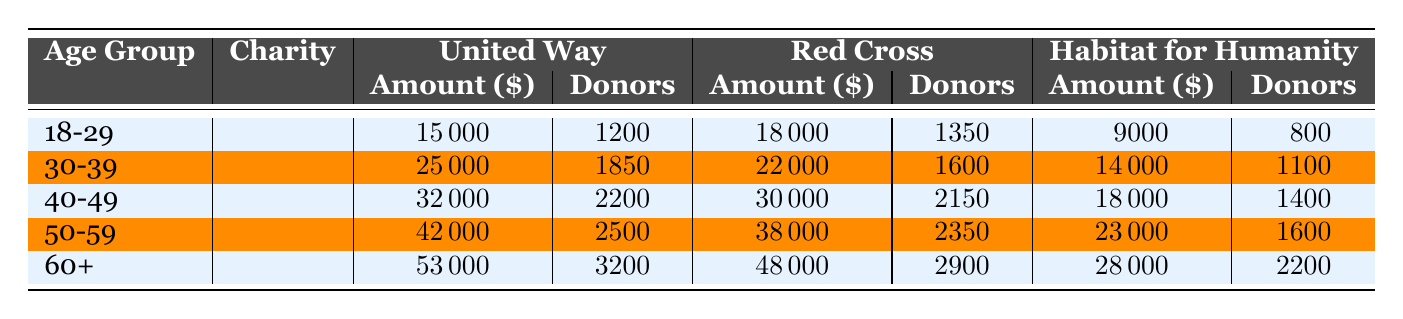What is the total amount donated by the 50-59 age group to the United Way? To find the total amount donated by the 50-59 age group to the United Way, we look at the "United Way" row under that age group, which shows the amount donated is 42000.00.
Answer: 42000 How many donors contributed to Habitat for Humanity from the 30-39 age group? The table shows that the number of donors for Habitat for Humanity in the 30-39 age group is 1100, as indicated in that row.
Answer: 1100 Which charity received the highest total amount from the 60+ age group? We compare the amounts donated to the three charities listed for the 60+ age group: United Way received 53000, Red Cross 48000, and Habitat for Humanity 28000. The highest amount is 53000 from United Way.
Answer: United Way What is the average donation amount for the Red Cross across all age groups? We sum the amounts donated to the Red Cross: 18000 + 22000 + 30000 + 38000 + 48000 = 155000. There are 5 age groups, so we divide the total by 5: 155000 / 5 = 31000.
Answer: 31000 True or False: The number of donors for Red Cross in the 50-59 age group is greater than the number of donors in the 18-29 age group. For the Red Cross in the 50-59 age group, the number of donors is 2350, while in the 18-29 group, it is 1350. Since 2350 is greater than 1350, the statement is true.
Answer: True What is the difference in the total number of donors between the 40-49 and 60+ age groups? For 40-49 age group, the total number of donors is 2200 + 2150 + 1400 = 5750. For 60+, the total is 3200 + 2900 + 2200 = 8300. The difference is 8300 - 5750 = 2550.
Answer: 2550 Identify the age group with the highest total donations overall. We calculate the total donations for each age group: 18-29: 15000 + 18000 + 9000 = 42000, 30-39: 25000 + 22000 + 14000 = 61000, 40-49: 32000 + 30000 + 18000 = 80000, 50-59: 42000 + 38000 + 23000 = 103000, and 60+: 53000 + 48000 + 28000 = 129000. The 60+ age group has the highest total donations.
Answer: 60+ 